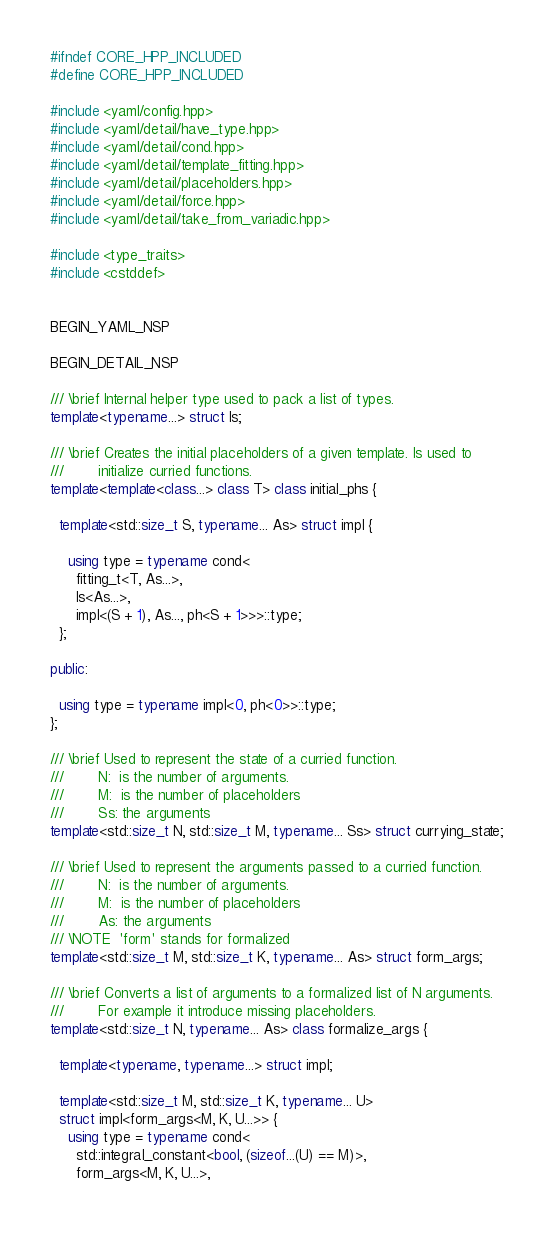<code> <loc_0><loc_0><loc_500><loc_500><_C++_>#ifndef CORE_HPP_INCLUDED
#define CORE_HPP_INCLUDED

#include <yaml/config.hpp>
#include <yaml/detail/have_type.hpp>
#include <yaml/detail/cond.hpp>
#include <yaml/detail/template_fitting.hpp>
#include <yaml/detail/placeholders.hpp>
#include <yaml/detail/force.hpp>
#include <yaml/detail/take_from_variadic.hpp>

#include <type_traits>
#include <cstddef>


BEGIN_YAML_NSP

BEGIN_DETAIL_NSP

/// \brief Internal helper type used to pack a list of types.
template<typename...> struct ls;

/// \brief Creates the initial placeholders of a given template. Is used to 
///        initialize curried functions.
template<template<class...> class T> class initial_phs { 

  template<std::size_t S, typename... As> struct impl {

    using type = typename cond<
      fitting_t<T, As...>,
      ls<As...>,
      impl<(S + 1), As..., ph<S + 1>>>::type;
  };

public:

  using type = typename impl<0, ph<0>>::type;
};

/// \brief Used to represent the state of a curried function.
///        N:  is the number of arguments.
///        M:  is the number of placeholders
///        Ss: the arguments
template<std::size_t N, std::size_t M, typename... Ss> struct currying_state;

/// \brief Used to represent the arguments passed to a curried function.
///        N:  is the number of arguments.
///        M:  is the number of placeholders
///        As: the arguments
/// \NOTE  'form' stands for formalized
template<std::size_t M, std::size_t K, typename... As> struct form_args;

/// \brief Converts a list of arguments to a formalized list of N arguments.
///        For example it introduce missing placeholders.
template<std::size_t N, typename... As> class formalize_args { 

  template<typename, typename...> struct impl;

  template<std::size_t M, std::size_t K, typename... U>
  struct impl<form_args<M, K, U...>> {
    using type = typename cond<
      std::integral_constant<bool, (sizeof...(U) == M)>,
      form_args<M, K, U...>,</code> 